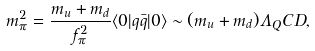<formula> <loc_0><loc_0><loc_500><loc_500>m _ { \pi } ^ { 2 } = \frac { m _ { u } + m _ { d } } { f _ { \pi } ^ { 2 } } \langle 0 | q \bar { q } | 0 \rangle \sim ( m _ { u } + m _ { d } ) \Lambda _ { Q } C D ,</formula> 